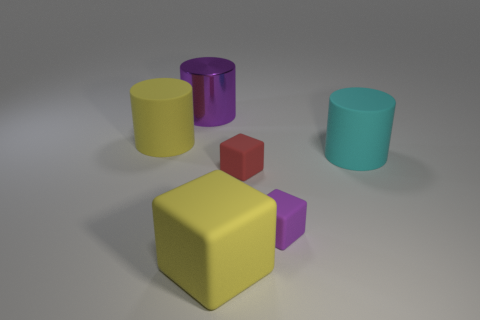If you had to guess, what purpose do these objects serve? These objects do not seem to serve a functional purpose. Given their plain appearance and varied shapes, it's likely that they are part of a geometric shape set, possibly used for educational purposes or 3D modeling. 